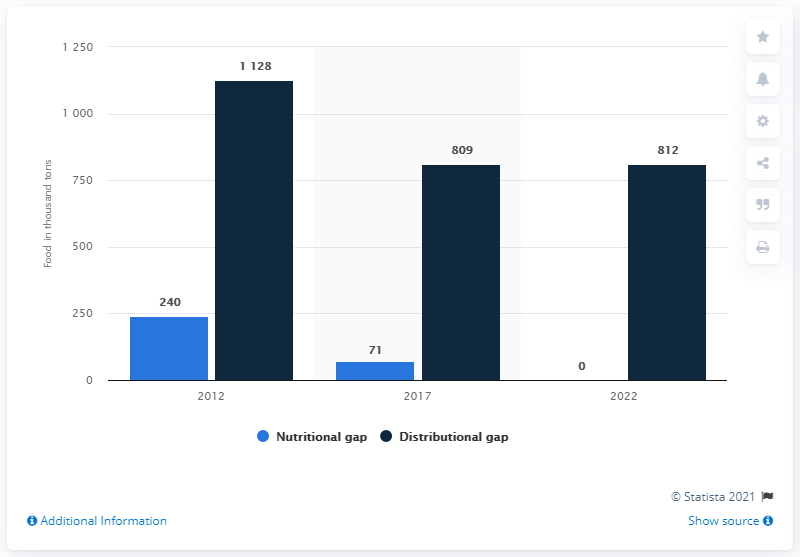Specify some key components in this picture. The food distribution gap in Latin America and the Caribbean is projected to end in the year 2022. The difference between the smallest acceptable level of nutrition and the largest acceptable level of calorie distribution, when combined, is equal to 1128. In 2022, the bar that is 0 is the Nutritional gap. 